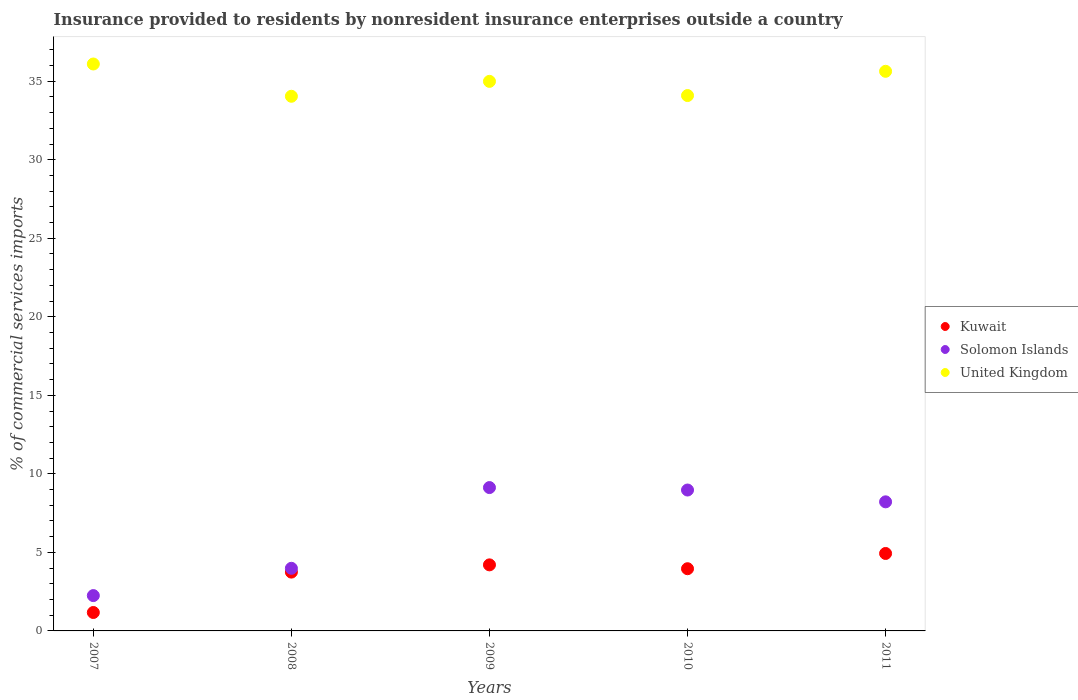What is the Insurance provided to residents in Kuwait in 2010?
Provide a succinct answer. 3.96. Across all years, what is the maximum Insurance provided to residents in United Kingdom?
Make the answer very short. 36.1. Across all years, what is the minimum Insurance provided to residents in Solomon Islands?
Your answer should be very brief. 2.25. In which year was the Insurance provided to residents in Solomon Islands minimum?
Your answer should be compact. 2007. What is the total Insurance provided to residents in Kuwait in the graph?
Offer a terse response. 18.02. What is the difference between the Insurance provided to residents in Solomon Islands in 2008 and that in 2011?
Your response must be concise. -4.23. What is the difference between the Insurance provided to residents in Kuwait in 2011 and the Insurance provided to residents in Solomon Islands in 2008?
Ensure brevity in your answer.  0.94. What is the average Insurance provided to residents in Solomon Islands per year?
Your answer should be compact. 6.51. In the year 2007, what is the difference between the Insurance provided to residents in Kuwait and Insurance provided to residents in Solomon Islands?
Offer a terse response. -1.08. In how many years, is the Insurance provided to residents in United Kingdom greater than 12 %?
Your answer should be compact. 5. What is the ratio of the Insurance provided to residents in Kuwait in 2008 to that in 2011?
Your answer should be compact. 0.76. Is the difference between the Insurance provided to residents in Kuwait in 2008 and 2010 greater than the difference between the Insurance provided to residents in Solomon Islands in 2008 and 2010?
Give a very brief answer. Yes. What is the difference between the highest and the second highest Insurance provided to residents in Kuwait?
Make the answer very short. 0.72. What is the difference between the highest and the lowest Insurance provided to residents in United Kingdom?
Your answer should be compact. 2.05. In how many years, is the Insurance provided to residents in United Kingdom greater than the average Insurance provided to residents in United Kingdom taken over all years?
Make the answer very short. 3. Is the sum of the Insurance provided to residents in Solomon Islands in 2010 and 2011 greater than the maximum Insurance provided to residents in Kuwait across all years?
Ensure brevity in your answer.  Yes. Does the Insurance provided to residents in Solomon Islands monotonically increase over the years?
Make the answer very short. No. Is the Insurance provided to residents in United Kingdom strictly greater than the Insurance provided to residents in Solomon Islands over the years?
Your answer should be very brief. Yes. How many dotlines are there?
Give a very brief answer. 3. Are the values on the major ticks of Y-axis written in scientific E-notation?
Offer a terse response. No. Does the graph contain any zero values?
Offer a very short reply. No. Does the graph contain grids?
Provide a succinct answer. No. How many legend labels are there?
Your answer should be compact. 3. How are the legend labels stacked?
Your response must be concise. Vertical. What is the title of the graph?
Keep it short and to the point. Insurance provided to residents by nonresident insurance enterprises outside a country. Does "Timor-Leste" appear as one of the legend labels in the graph?
Keep it short and to the point. No. What is the label or title of the Y-axis?
Your response must be concise. % of commercial services imports. What is the % of commercial services imports of Kuwait in 2007?
Provide a succinct answer. 1.17. What is the % of commercial services imports of Solomon Islands in 2007?
Your answer should be compact. 2.25. What is the % of commercial services imports in United Kingdom in 2007?
Your answer should be compact. 36.1. What is the % of commercial services imports in Kuwait in 2008?
Your answer should be very brief. 3.75. What is the % of commercial services imports of Solomon Islands in 2008?
Offer a very short reply. 3.99. What is the % of commercial services imports of United Kingdom in 2008?
Your answer should be compact. 34.04. What is the % of commercial services imports in Kuwait in 2009?
Keep it short and to the point. 4.21. What is the % of commercial services imports of Solomon Islands in 2009?
Ensure brevity in your answer.  9.13. What is the % of commercial services imports in United Kingdom in 2009?
Provide a short and direct response. 34.99. What is the % of commercial services imports of Kuwait in 2010?
Keep it short and to the point. 3.96. What is the % of commercial services imports of Solomon Islands in 2010?
Your answer should be very brief. 8.97. What is the % of commercial services imports in United Kingdom in 2010?
Provide a short and direct response. 34.09. What is the % of commercial services imports in Kuwait in 2011?
Make the answer very short. 4.93. What is the % of commercial services imports in Solomon Islands in 2011?
Your answer should be compact. 8.22. What is the % of commercial services imports in United Kingdom in 2011?
Give a very brief answer. 35.63. Across all years, what is the maximum % of commercial services imports in Kuwait?
Make the answer very short. 4.93. Across all years, what is the maximum % of commercial services imports of Solomon Islands?
Provide a succinct answer. 9.13. Across all years, what is the maximum % of commercial services imports in United Kingdom?
Make the answer very short. 36.1. Across all years, what is the minimum % of commercial services imports in Kuwait?
Ensure brevity in your answer.  1.17. Across all years, what is the minimum % of commercial services imports of Solomon Islands?
Your answer should be compact. 2.25. Across all years, what is the minimum % of commercial services imports of United Kingdom?
Your response must be concise. 34.04. What is the total % of commercial services imports of Kuwait in the graph?
Provide a short and direct response. 18.02. What is the total % of commercial services imports in Solomon Islands in the graph?
Keep it short and to the point. 32.55. What is the total % of commercial services imports of United Kingdom in the graph?
Provide a short and direct response. 174.85. What is the difference between the % of commercial services imports in Kuwait in 2007 and that in 2008?
Your answer should be compact. -2.57. What is the difference between the % of commercial services imports in Solomon Islands in 2007 and that in 2008?
Make the answer very short. -1.74. What is the difference between the % of commercial services imports in United Kingdom in 2007 and that in 2008?
Keep it short and to the point. 2.06. What is the difference between the % of commercial services imports of Kuwait in 2007 and that in 2009?
Your response must be concise. -3.03. What is the difference between the % of commercial services imports in Solomon Islands in 2007 and that in 2009?
Give a very brief answer. -6.88. What is the difference between the % of commercial services imports of United Kingdom in 2007 and that in 2009?
Provide a succinct answer. 1.11. What is the difference between the % of commercial services imports in Kuwait in 2007 and that in 2010?
Give a very brief answer. -2.79. What is the difference between the % of commercial services imports in Solomon Islands in 2007 and that in 2010?
Provide a succinct answer. -6.72. What is the difference between the % of commercial services imports in United Kingdom in 2007 and that in 2010?
Keep it short and to the point. 2.01. What is the difference between the % of commercial services imports of Kuwait in 2007 and that in 2011?
Offer a terse response. -3.76. What is the difference between the % of commercial services imports in Solomon Islands in 2007 and that in 2011?
Give a very brief answer. -5.97. What is the difference between the % of commercial services imports of United Kingdom in 2007 and that in 2011?
Your answer should be very brief. 0.47. What is the difference between the % of commercial services imports in Kuwait in 2008 and that in 2009?
Your answer should be compact. -0.46. What is the difference between the % of commercial services imports in Solomon Islands in 2008 and that in 2009?
Keep it short and to the point. -5.14. What is the difference between the % of commercial services imports in United Kingdom in 2008 and that in 2009?
Make the answer very short. -0.95. What is the difference between the % of commercial services imports in Kuwait in 2008 and that in 2010?
Offer a very short reply. -0.22. What is the difference between the % of commercial services imports in Solomon Islands in 2008 and that in 2010?
Your response must be concise. -4.98. What is the difference between the % of commercial services imports in United Kingdom in 2008 and that in 2010?
Offer a terse response. -0.05. What is the difference between the % of commercial services imports in Kuwait in 2008 and that in 2011?
Keep it short and to the point. -1.19. What is the difference between the % of commercial services imports in Solomon Islands in 2008 and that in 2011?
Your answer should be compact. -4.23. What is the difference between the % of commercial services imports in United Kingdom in 2008 and that in 2011?
Provide a short and direct response. -1.59. What is the difference between the % of commercial services imports in Kuwait in 2009 and that in 2010?
Ensure brevity in your answer.  0.25. What is the difference between the % of commercial services imports of Solomon Islands in 2009 and that in 2010?
Keep it short and to the point. 0.16. What is the difference between the % of commercial services imports of United Kingdom in 2009 and that in 2010?
Provide a succinct answer. 0.9. What is the difference between the % of commercial services imports of Kuwait in 2009 and that in 2011?
Give a very brief answer. -0.72. What is the difference between the % of commercial services imports in Solomon Islands in 2009 and that in 2011?
Your answer should be very brief. 0.91. What is the difference between the % of commercial services imports in United Kingdom in 2009 and that in 2011?
Give a very brief answer. -0.64. What is the difference between the % of commercial services imports in Kuwait in 2010 and that in 2011?
Provide a succinct answer. -0.97. What is the difference between the % of commercial services imports of Solomon Islands in 2010 and that in 2011?
Ensure brevity in your answer.  0.75. What is the difference between the % of commercial services imports in United Kingdom in 2010 and that in 2011?
Keep it short and to the point. -1.54. What is the difference between the % of commercial services imports in Kuwait in 2007 and the % of commercial services imports in Solomon Islands in 2008?
Offer a very short reply. -2.81. What is the difference between the % of commercial services imports of Kuwait in 2007 and the % of commercial services imports of United Kingdom in 2008?
Provide a succinct answer. -32.87. What is the difference between the % of commercial services imports in Solomon Islands in 2007 and the % of commercial services imports in United Kingdom in 2008?
Provide a succinct answer. -31.79. What is the difference between the % of commercial services imports in Kuwait in 2007 and the % of commercial services imports in Solomon Islands in 2009?
Your answer should be compact. -7.95. What is the difference between the % of commercial services imports in Kuwait in 2007 and the % of commercial services imports in United Kingdom in 2009?
Provide a short and direct response. -33.82. What is the difference between the % of commercial services imports in Solomon Islands in 2007 and the % of commercial services imports in United Kingdom in 2009?
Ensure brevity in your answer.  -32.74. What is the difference between the % of commercial services imports in Kuwait in 2007 and the % of commercial services imports in Solomon Islands in 2010?
Your answer should be compact. -7.8. What is the difference between the % of commercial services imports of Kuwait in 2007 and the % of commercial services imports of United Kingdom in 2010?
Ensure brevity in your answer.  -32.92. What is the difference between the % of commercial services imports in Solomon Islands in 2007 and the % of commercial services imports in United Kingdom in 2010?
Your answer should be compact. -31.84. What is the difference between the % of commercial services imports in Kuwait in 2007 and the % of commercial services imports in Solomon Islands in 2011?
Ensure brevity in your answer.  -7.05. What is the difference between the % of commercial services imports in Kuwait in 2007 and the % of commercial services imports in United Kingdom in 2011?
Your answer should be compact. -34.46. What is the difference between the % of commercial services imports of Solomon Islands in 2007 and the % of commercial services imports of United Kingdom in 2011?
Offer a terse response. -33.38. What is the difference between the % of commercial services imports of Kuwait in 2008 and the % of commercial services imports of Solomon Islands in 2009?
Give a very brief answer. -5.38. What is the difference between the % of commercial services imports of Kuwait in 2008 and the % of commercial services imports of United Kingdom in 2009?
Make the answer very short. -31.25. What is the difference between the % of commercial services imports of Solomon Islands in 2008 and the % of commercial services imports of United Kingdom in 2009?
Your answer should be very brief. -31.01. What is the difference between the % of commercial services imports in Kuwait in 2008 and the % of commercial services imports in Solomon Islands in 2010?
Your response must be concise. -5.23. What is the difference between the % of commercial services imports of Kuwait in 2008 and the % of commercial services imports of United Kingdom in 2010?
Keep it short and to the point. -30.34. What is the difference between the % of commercial services imports in Solomon Islands in 2008 and the % of commercial services imports in United Kingdom in 2010?
Your response must be concise. -30.1. What is the difference between the % of commercial services imports in Kuwait in 2008 and the % of commercial services imports in Solomon Islands in 2011?
Your response must be concise. -4.47. What is the difference between the % of commercial services imports of Kuwait in 2008 and the % of commercial services imports of United Kingdom in 2011?
Make the answer very short. -31.89. What is the difference between the % of commercial services imports of Solomon Islands in 2008 and the % of commercial services imports of United Kingdom in 2011?
Offer a terse response. -31.65. What is the difference between the % of commercial services imports in Kuwait in 2009 and the % of commercial services imports in Solomon Islands in 2010?
Make the answer very short. -4.76. What is the difference between the % of commercial services imports in Kuwait in 2009 and the % of commercial services imports in United Kingdom in 2010?
Keep it short and to the point. -29.88. What is the difference between the % of commercial services imports in Solomon Islands in 2009 and the % of commercial services imports in United Kingdom in 2010?
Keep it short and to the point. -24.96. What is the difference between the % of commercial services imports in Kuwait in 2009 and the % of commercial services imports in Solomon Islands in 2011?
Keep it short and to the point. -4.01. What is the difference between the % of commercial services imports in Kuwait in 2009 and the % of commercial services imports in United Kingdom in 2011?
Your response must be concise. -31.43. What is the difference between the % of commercial services imports in Solomon Islands in 2009 and the % of commercial services imports in United Kingdom in 2011?
Provide a succinct answer. -26.5. What is the difference between the % of commercial services imports in Kuwait in 2010 and the % of commercial services imports in Solomon Islands in 2011?
Offer a very short reply. -4.26. What is the difference between the % of commercial services imports of Kuwait in 2010 and the % of commercial services imports of United Kingdom in 2011?
Keep it short and to the point. -31.67. What is the difference between the % of commercial services imports of Solomon Islands in 2010 and the % of commercial services imports of United Kingdom in 2011?
Offer a very short reply. -26.66. What is the average % of commercial services imports of Kuwait per year?
Your response must be concise. 3.6. What is the average % of commercial services imports in Solomon Islands per year?
Provide a succinct answer. 6.51. What is the average % of commercial services imports in United Kingdom per year?
Provide a succinct answer. 34.97. In the year 2007, what is the difference between the % of commercial services imports of Kuwait and % of commercial services imports of Solomon Islands?
Offer a very short reply. -1.08. In the year 2007, what is the difference between the % of commercial services imports of Kuwait and % of commercial services imports of United Kingdom?
Your answer should be compact. -34.92. In the year 2007, what is the difference between the % of commercial services imports in Solomon Islands and % of commercial services imports in United Kingdom?
Give a very brief answer. -33.85. In the year 2008, what is the difference between the % of commercial services imports of Kuwait and % of commercial services imports of Solomon Islands?
Ensure brevity in your answer.  -0.24. In the year 2008, what is the difference between the % of commercial services imports in Kuwait and % of commercial services imports in United Kingdom?
Provide a succinct answer. -30.3. In the year 2008, what is the difference between the % of commercial services imports in Solomon Islands and % of commercial services imports in United Kingdom?
Your answer should be very brief. -30.06. In the year 2009, what is the difference between the % of commercial services imports in Kuwait and % of commercial services imports in Solomon Islands?
Offer a terse response. -4.92. In the year 2009, what is the difference between the % of commercial services imports of Kuwait and % of commercial services imports of United Kingdom?
Ensure brevity in your answer.  -30.79. In the year 2009, what is the difference between the % of commercial services imports in Solomon Islands and % of commercial services imports in United Kingdom?
Provide a succinct answer. -25.86. In the year 2010, what is the difference between the % of commercial services imports of Kuwait and % of commercial services imports of Solomon Islands?
Make the answer very short. -5.01. In the year 2010, what is the difference between the % of commercial services imports of Kuwait and % of commercial services imports of United Kingdom?
Make the answer very short. -30.13. In the year 2010, what is the difference between the % of commercial services imports in Solomon Islands and % of commercial services imports in United Kingdom?
Offer a terse response. -25.12. In the year 2011, what is the difference between the % of commercial services imports of Kuwait and % of commercial services imports of Solomon Islands?
Your answer should be compact. -3.29. In the year 2011, what is the difference between the % of commercial services imports in Kuwait and % of commercial services imports in United Kingdom?
Provide a short and direct response. -30.7. In the year 2011, what is the difference between the % of commercial services imports of Solomon Islands and % of commercial services imports of United Kingdom?
Provide a short and direct response. -27.41. What is the ratio of the % of commercial services imports in Kuwait in 2007 to that in 2008?
Provide a short and direct response. 0.31. What is the ratio of the % of commercial services imports in Solomon Islands in 2007 to that in 2008?
Provide a succinct answer. 0.56. What is the ratio of the % of commercial services imports of United Kingdom in 2007 to that in 2008?
Offer a terse response. 1.06. What is the ratio of the % of commercial services imports in Kuwait in 2007 to that in 2009?
Make the answer very short. 0.28. What is the ratio of the % of commercial services imports of Solomon Islands in 2007 to that in 2009?
Ensure brevity in your answer.  0.25. What is the ratio of the % of commercial services imports in United Kingdom in 2007 to that in 2009?
Make the answer very short. 1.03. What is the ratio of the % of commercial services imports of Kuwait in 2007 to that in 2010?
Your response must be concise. 0.3. What is the ratio of the % of commercial services imports of Solomon Islands in 2007 to that in 2010?
Provide a succinct answer. 0.25. What is the ratio of the % of commercial services imports in United Kingdom in 2007 to that in 2010?
Give a very brief answer. 1.06. What is the ratio of the % of commercial services imports of Kuwait in 2007 to that in 2011?
Provide a succinct answer. 0.24. What is the ratio of the % of commercial services imports of Solomon Islands in 2007 to that in 2011?
Give a very brief answer. 0.27. What is the ratio of the % of commercial services imports of United Kingdom in 2007 to that in 2011?
Make the answer very short. 1.01. What is the ratio of the % of commercial services imports in Kuwait in 2008 to that in 2009?
Keep it short and to the point. 0.89. What is the ratio of the % of commercial services imports of Solomon Islands in 2008 to that in 2009?
Make the answer very short. 0.44. What is the ratio of the % of commercial services imports of United Kingdom in 2008 to that in 2009?
Offer a very short reply. 0.97. What is the ratio of the % of commercial services imports in Kuwait in 2008 to that in 2010?
Give a very brief answer. 0.95. What is the ratio of the % of commercial services imports in Solomon Islands in 2008 to that in 2010?
Offer a very short reply. 0.44. What is the ratio of the % of commercial services imports of United Kingdom in 2008 to that in 2010?
Offer a terse response. 1. What is the ratio of the % of commercial services imports in Kuwait in 2008 to that in 2011?
Provide a succinct answer. 0.76. What is the ratio of the % of commercial services imports in Solomon Islands in 2008 to that in 2011?
Provide a short and direct response. 0.49. What is the ratio of the % of commercial services imports in United Kingdom in 2008 to that in 2011?
Your response must be concise. 0.96. What is the ratio of the % of commercial services imports of Kuwait in 2009 to that in 2010?
Offer a very short reply. 1.06. What is the ratio of the % of commercial services imports of Solomon Islands in 2009 to that in 2010?
Ensure brevity in your answer.  1.02. What is the ratio of the % of commercial services imports in United Kingdom in 2009 to that in 2010?
Provide a short and direct response. 1.03. What is the ratio of the % of commercial services imports in Kuwait in 2009 to that in 2011?
Offer a very short reply. 0.85. What is the ratio of the % of commercial services imports of Solomon Islands in 2009 to that in 2011?
Offer a very short reply. 1.11. What is the ratio of the % of commercial services imports of United Kingdom in 2009 to that in 2011?
Provide a succinct answer. 0.98. What is the ratio of the % of commercial services imports of Kuwait in 2010 to that in 2011?
Make the answer very short. 0.8. What is the ratio of the % of commercial services imports in Solomon Islands in 2010 to that in 2011?
Your answer should be very brief. 1.09. What is the ratio of the % of commercial services imports of United Kingdom in 2010 to that in 2011?
Make the answer very short. 0.96. What is the difference between the highest and the second highest % of commercial services imports of Kuwait?
Your answer should be very brief. 0.72. What is the difference between the highest and the second highest % of commercial services imports in Solomon Islands?
Your answer should be compact. 0.16. What is the difference between the highest and the second highest % of commercial services imports in United Kingdom?
Provide a short and direct response. 0.47. What is the difference between the highest and the lowest % of commercial services imports in Kuwait?
Ensure brevity in your answer.  3.76. What is the difference between the highest and the lowest % of commercial services imports of Solomon Islands?
Make the answer very short. 6.88. What is the difference between the highest and the lowest % of commercial services imports of United Kingdom?
Give a very brief answer. 2.06. 